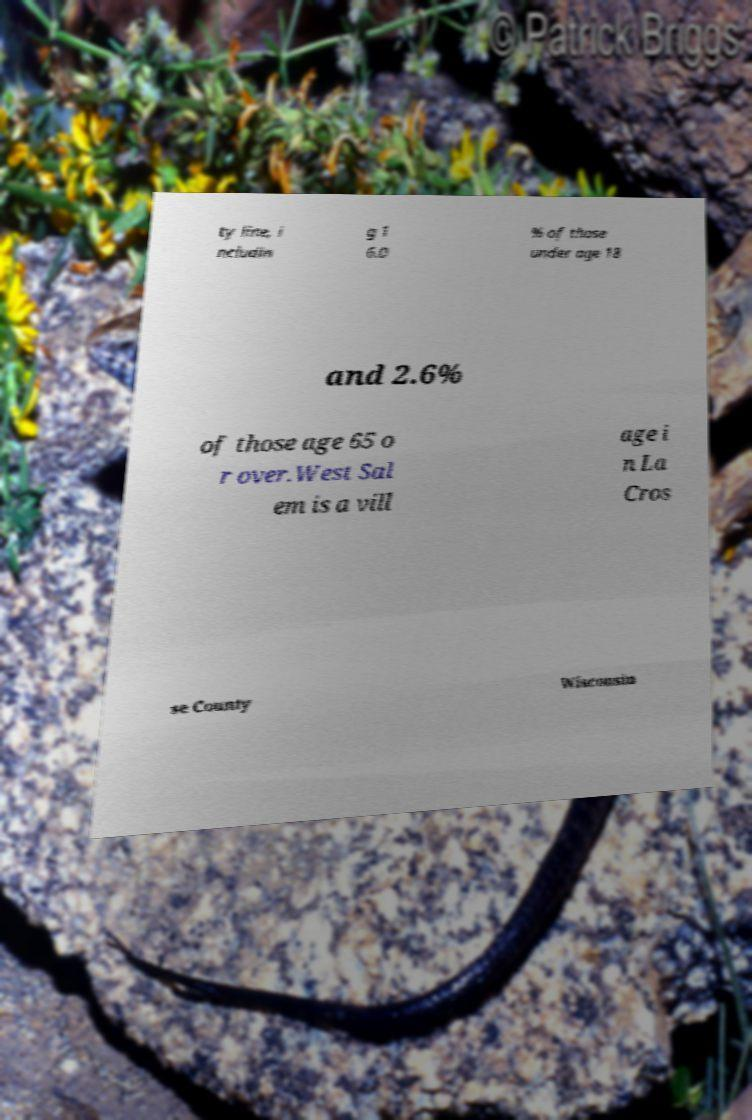What messages or text are displayed in this image? I need them in a readable, typed format. ty line, i ncludin g 1 6.0 % of those under age 18 and 2.6% of those age 65 o r over.West Sal em is a vill age i n La Cros se County Wisconsin 